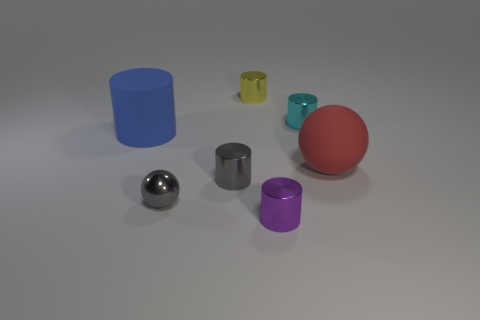Is the number of tiny gray balls less than the number of cylinders?
Give a very brief answer. Yes. What is the shape of the small metal object that is in front of the cyan thing and behind the tiny metallic ball?
Your response must be concise. Cylinder. How many large blue metallic balls are there?
Keep it short and to the point. 0. The tiny gray object that is behind the metal thing to the left of the gray metal object right of the shiny sphere is made of what material?
Your answer should be compact. Metal. What number of cylinders are behind the big thing that is behind the red matte ball?
Ensure brevity in your answer.  2. The other matte thing that is the same shape as the tiny yellow thing is what color?
Keep it short and to the point. Blue. Does the cyan cylinder have the same material as the yellow object?
Keep it short and to the point. Yes. How many balls are either big blue things or purple objects?
Your response must be concise. 0. What size is the cyan metallic object behind the big rubber thing that is on the left side of the large object to the right of the yellow object?
Your response must be concise. Small. What is the size of the gray metal object that is the same shape as the tiny cyan metal thing?
Provide a short and direct response. Small. 